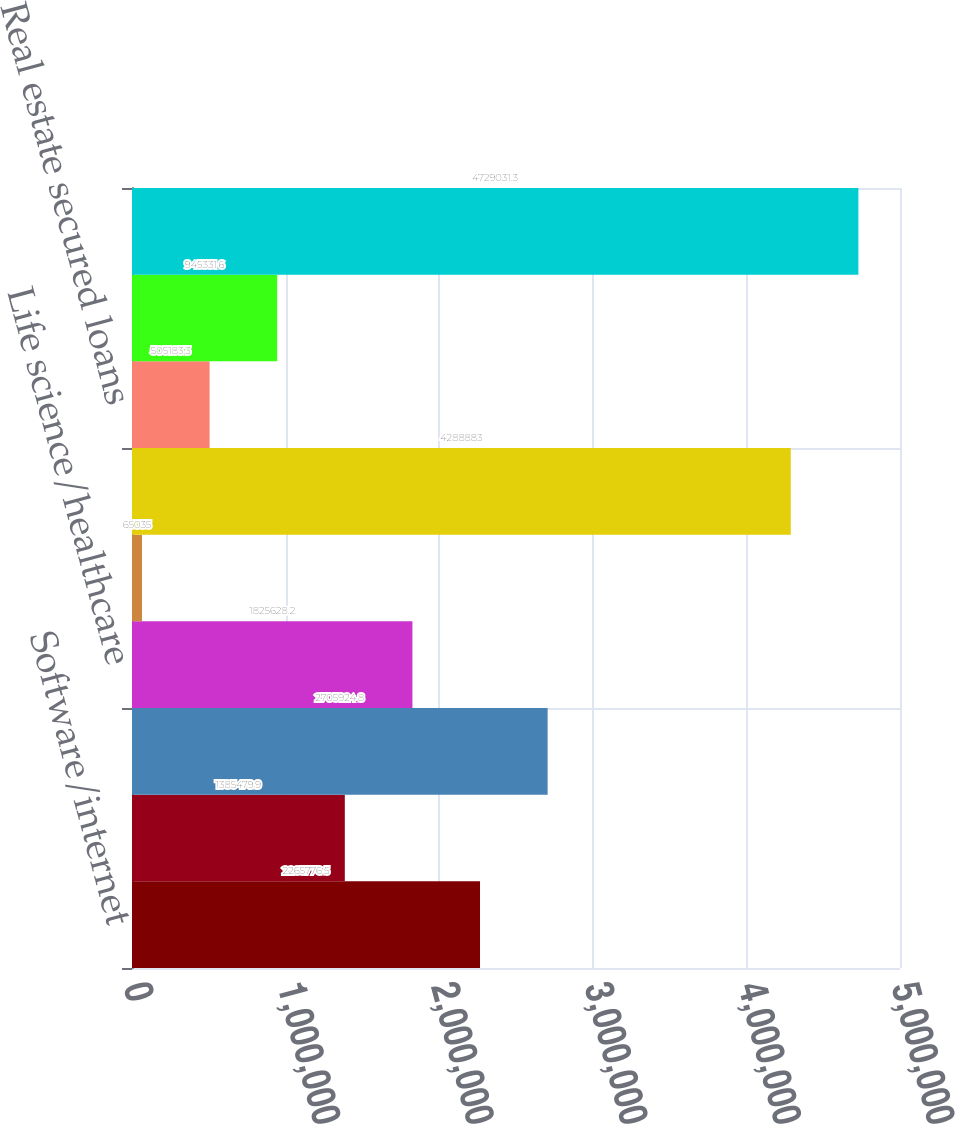Convert chart to OTSL. <chart><loc_0><loc_0><loc_500><loc_500><bar_chart><fcel>Software/internet<fcel>Hardware<fcel>Private equity/venture capital<fcel>Life science/healthcare<fcel>Premium wine<fcel>Commercial loans<fcel>Real estate secured loans<fcel>Consumer loans<fcel>Total gross loans<nl><fcel>2.26578e+06<fcel>1.38548e+06<fcel>2.70592e+06<fcel>1.82563e+06<fcel>65035<fcel>4.28888e+06<fcel>505183<fcel>945332<fcel>4.72903e+06<nl></chart> 